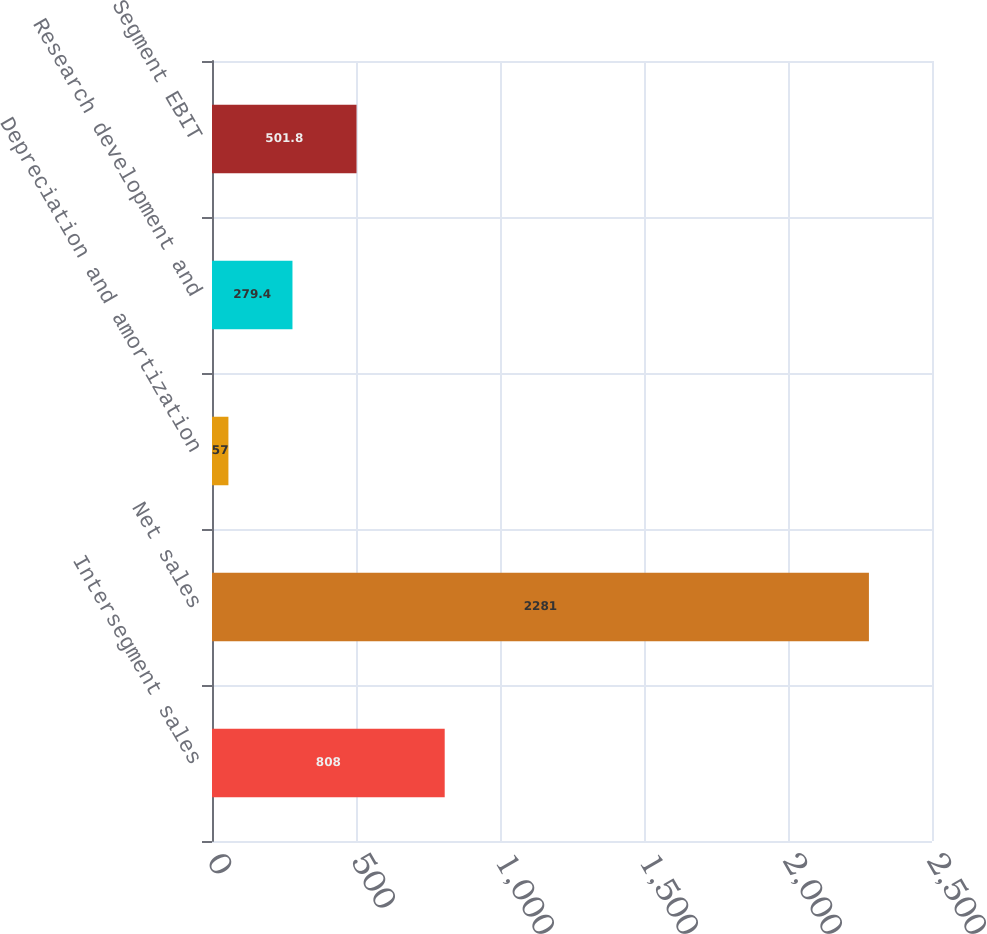<chart> <loc_0><loc_0><loc_500><loc_500><bar_chart><fcel>Intersegment sales<fcel>Net sales<fcel>Depreciation and amortization<fcel>Research development and<fcel>Segment EBIT<nl><fcel>808<fcel>2281<fcel>57<fcel>279.4<fcel>501.8<nl></chart> 